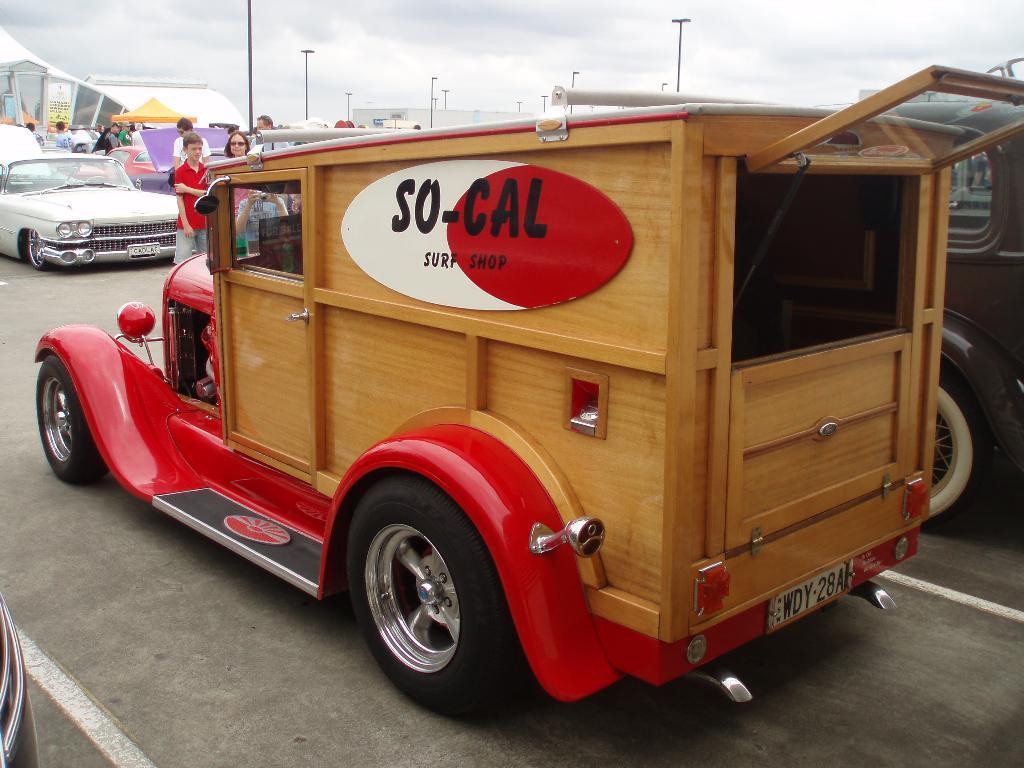Please provide a concise description of this image. In this picture , I can see car a three cars which is parked after that two person who are standing next i can see few electrical poles which includes lights , Here we can see few people and all the motor vehicles are parked in , Finally i can see a sky. 